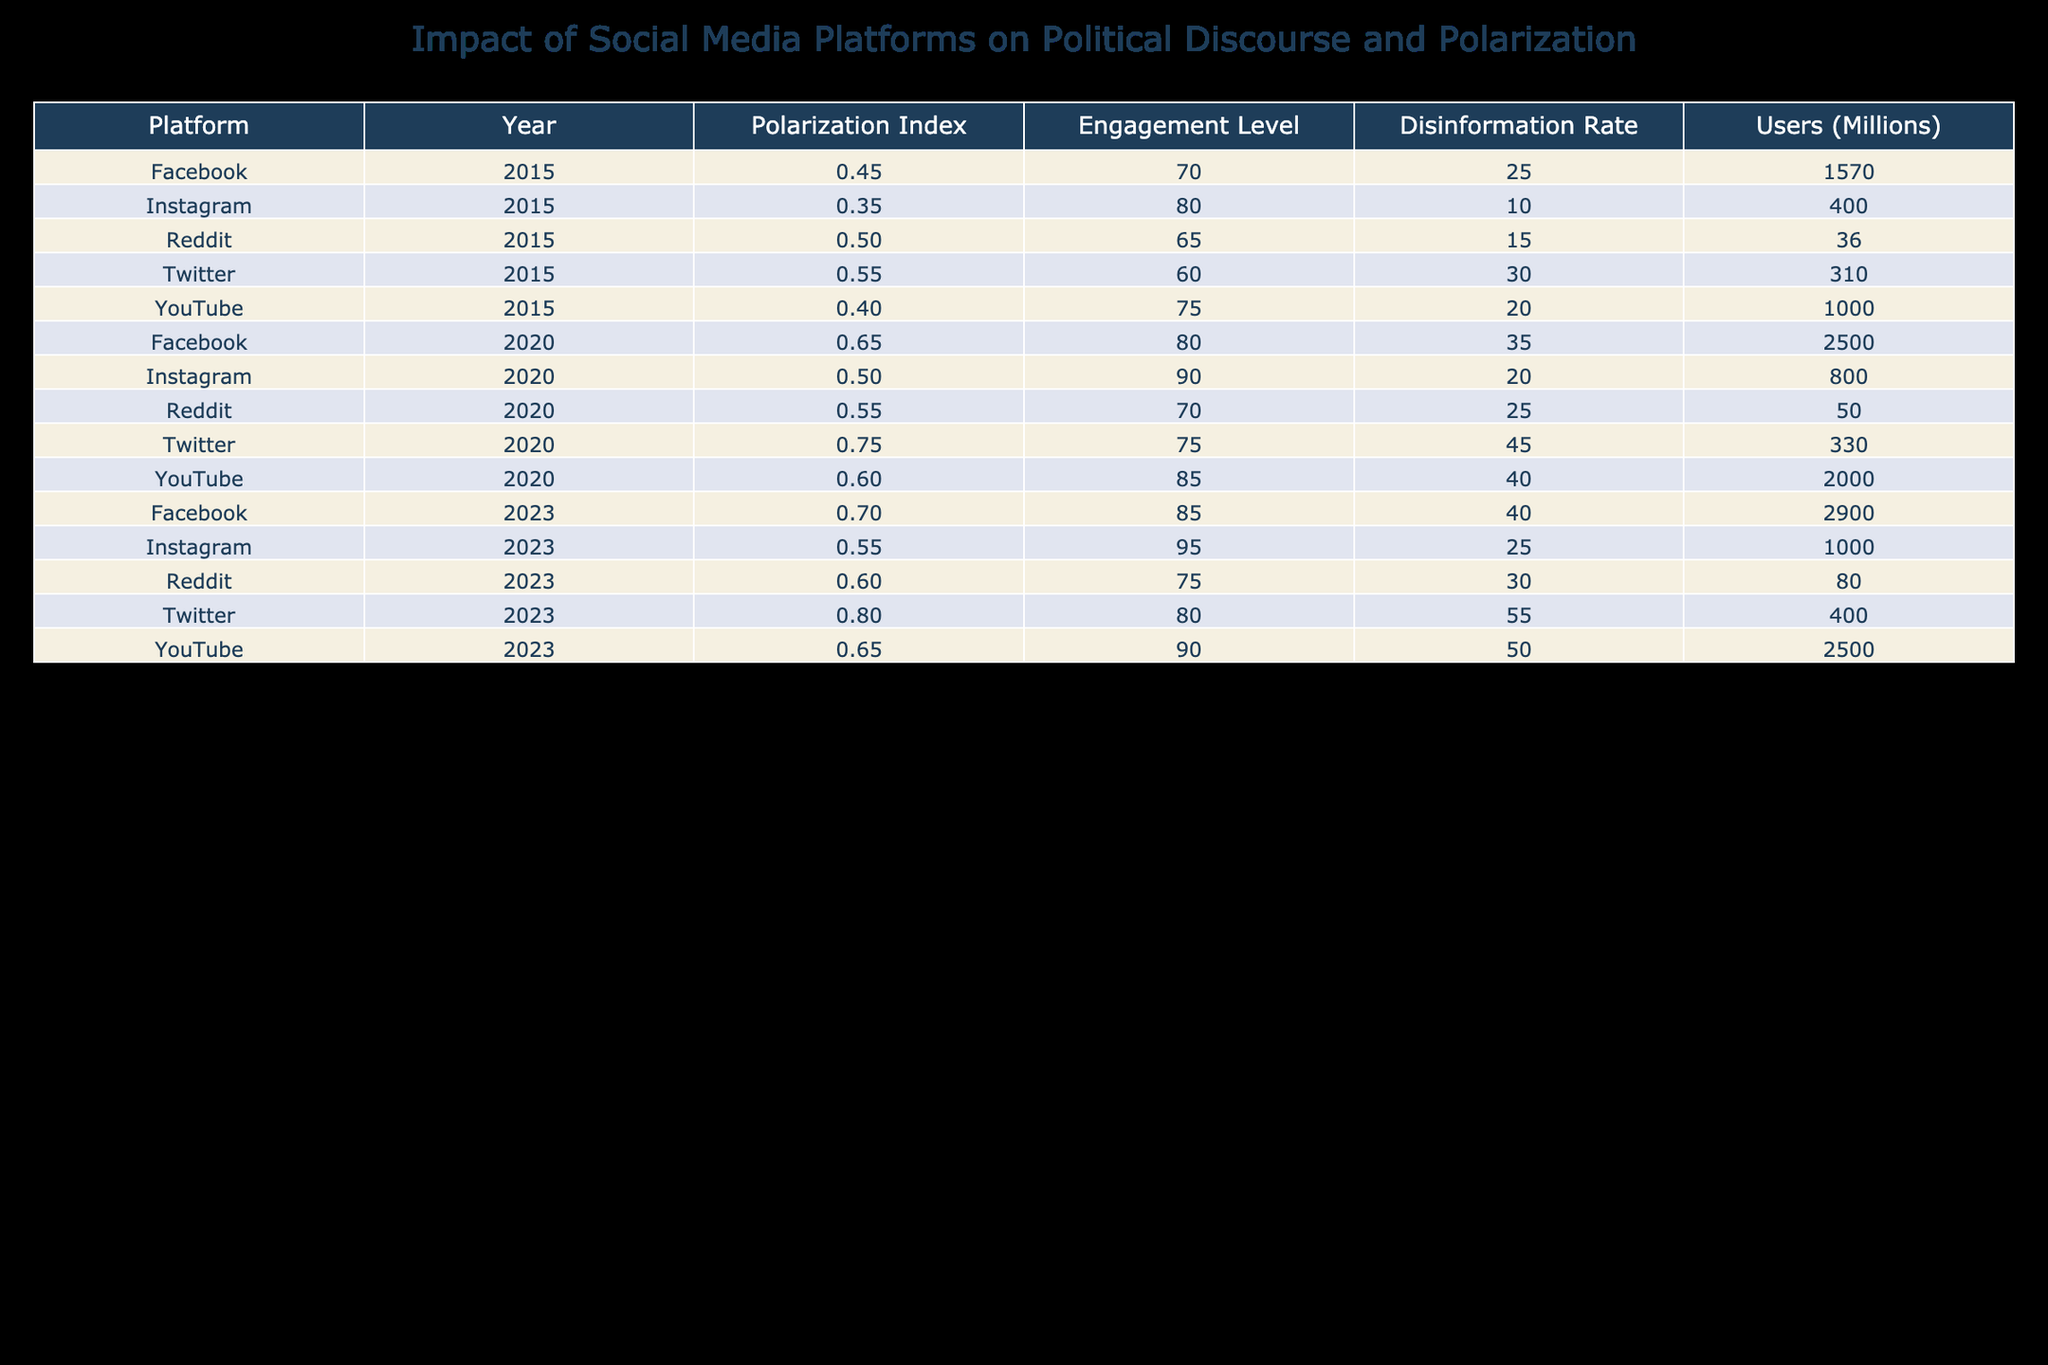What was the Polarization Index for Twitter in 2020? In the table, locate the row for Twitter in the year 2020; the Polarization Index listed for that row is 0.75.
Answer: 0.75 Which platform had the highest Engagement Level in 2023? Look at the Engagement Level column for the year 2023; the highest value listed is 95, corresponding to Instagram.
Answer: Instagram What is the difference in Polarization Index between Facebook in 2015 and Facebook in 2023? First, find the Polarization Index for Facebook in 2015 (0.45) and in 2023 (0.70). Then, calculate the difference: 0.70 - 0.45 = 0.25.
Answer: 0.25 Did the Disinformation Rate for YouTube increase from 2015 to 2023? Compare the Disinformation Rate for YouTube in 2015 (20) and 2023 (50). Since 50 is greater than 20, the Disinformation Rate did indeed increase.
Answer: Yes What was the total number of Users (Millions) across all platforms in 2020? The Users (Millions) values for 2020 are: Facebook (2500), Twitter (330), YouTube (2000), Reddit (50), and Instagram (800). Summing these gives: 2500 + 330 + 2000 + 50 + 800 = 4680.
Answer: 4680 Which platform showed the greatest increase in Polarization Index from 2015 to 2023? Calculate the change for each platform: Facebook from 0.45 to 0.70 (+0.25), Twitter from 0.55 to 0.80 (+0.25), YouTube from 0.40 to 0.65 (+0.25), Reddit from 0.50 to 0.60 (+0.10), and Instagram from 0.35 to 0.55 (+0.20). All platforms increased by 0.25 except Reddit and Instagram, hence there’s a tie between Facebook, Twitter, and YouTube for the greatest increase.
Answer: Facebook, Twitter, YouTube Which platform had the lowest Disinformation Rate in 2015? In the Disinformation Rate column for 2015, the lowest value is 10, which corresponds to Instagram.
Answer: Instagram Is it true that the Polarization Index for Reddit in 2020 was higher than that for Instagram? Check the Polarization Index: Reddit in 2020 is 0.55 while Instagram is 0.50; since 0.55 is higher than 0.50, the statement is true.
Answer: Yes 